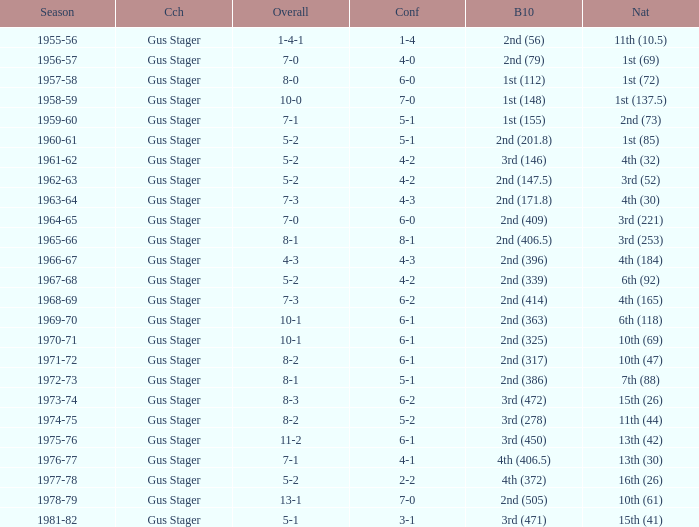What is the Season with a Big Ten that is 2nd (386)? 1972-73. 